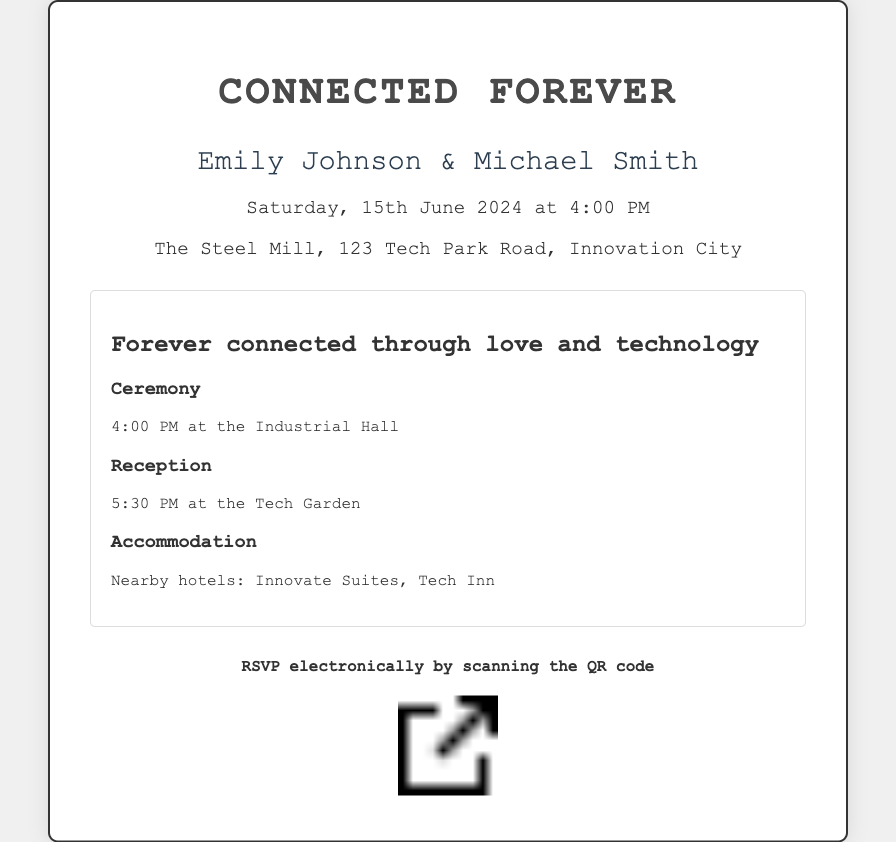What are the names of the couple? The document mentions the names of the couple prominently at the top, which are Emily Johnson and Michael Smith.
Answer: Emily Johnson & Michael Smith What is the date of the wedding? The date of the wedding is clearly stated in the document, which is Saturday, 15th June 2024.
Answer: Saturday, 15th June 2024 What time does the ceremony start? The document specifies the start time of the ceremony, which is at 4:00 PM.
Answer: 4:00 PM Where will the reception take place? The reception venue is detailed in the document, which states it will take place at the Tech Garden.
Answer: Tech Garden What type of RSVP method is provided? The invitation provides a method for RSVP by scanning a QR code, indicated in the RSVP section.
Answer: QR code What is the theme of the invitation? The title of the invitation indicates that its theme is "Connected Forever," symbolizing a blend of love and technology.
Answer: Connected Forever What is the location of the wedding venue? The venue is mentioned in the invitation as "The Steel Mill, 123 Tech Park Road, Innovation City."
Answer: The Steel Mill, 123 Tech Park Road, Innovation City What is the time for the reception? The invitation outlines the reception time, which is clearly stated as 5:30 PM.
Answer: 5:30 PM What are the nearby hotels mentioned? The document lists two nearby hotels for accommodation: Innovate Suites and Tech Inn.
Answer: Innovate Suites, Tech Inn 